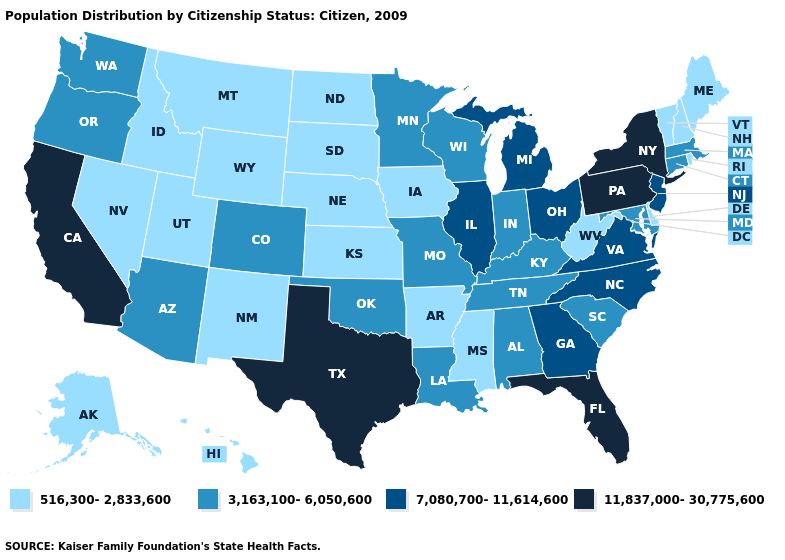What is the value of Iowa?
Be succinct. 516,300-2,833,600. Name the states that have a value in the range 7,080,700-11,614,600?
Write a very short answer. Georgia, Illinois, Michigan, New Jersey, North Carolina, Ohio, Virginia. Name the states that have a value in the range 3,163,100-6,050,600?
Keep it brief. Alabama, Arizona, Colorado, Connecticut, Indiana, Kentucky, Louisiana, Maryland, Massachusetts, Minnesota, Missouri, Oklahoma, Oregon, South Carolina, Tennessee, Washington, Wisconsin. What is the value of Connecticut?
Concise answer only. 3,163,100-6,050,600. Name the states that have a value in the range 11,837,000-30,775,600?
Short answer required. California, Florida, New York, Pennsylvania, Texas. Among the states that border Tennessee , does Georgia have the lowest value?
Write a very short answer. No. Does Iowa have the highest value in the USA?
Keep it brief. No. What is the lowest value in the USA?
Give a very brief answer. 516,300-2,833,600. What is the highest value in the West ?
Keep it brief. 11,837,000-30,775,600. Name the states that have a value in the range 516,300-2,833,600?
Keep it brief. Alaska, Arkansas, Delaware, Hawaii, Idaho, Iowa, Kansas, Maine, Mississippi, Montana, Nebraska, Nevada, New Hampshire, New Mexico, North Dakota, Rhode Island, South Dakota, Utah, Vermont, West Virginia, Wyoming. Which states have the highest value in the USA?
Write a very short answer. California, Florida, New York, Pennsylvania, Texas. Does Hawaii have the lowest value in the USA?
Quick response, please. Yes. What is the lowest value in states that border Michigan?
Be succinct. 3,163,100-6,050,600. Among the states that border Washington , does Oregon have the highest value?
Be succinct. Yes. Name the states that have a value in the range 7,080,700-11,614,600?
Short answer required. Georgia, Illinois, Michigan, New Jersey, North Carolina, Ohio, Virginia. 